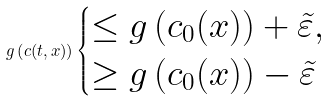Convert formula to latex. <formula><loc_0><loc_0><loc_500><loc_500>g \left ( c ( t , x ) \right ) \begin{cases} \leq g \left ( c _ { 0 } ( x ) \right ) + \tilde { \varepsilon } , \\ \geq g \left ( c _ { 0 } ( x ) \right ) - \tilde { \varepsilon } \end{cases}</formula> 